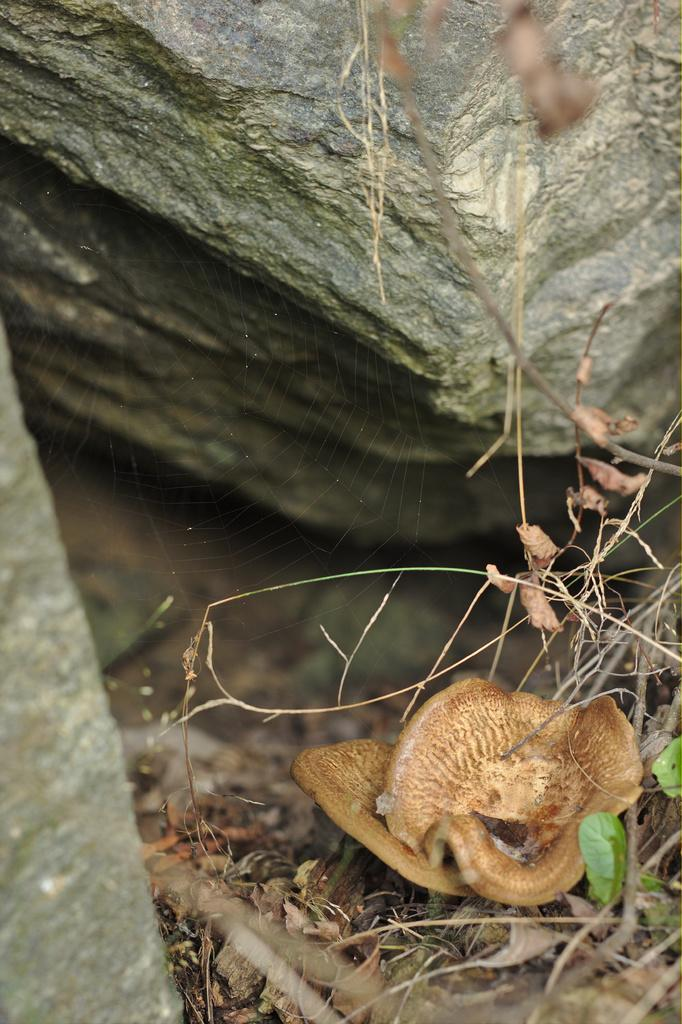What type of natural elements can be seen in the image? There are rocks and grass in the image. Can you describe the texture of the rocks? The texture of the rocks cannot be determined from the image alone. What type of vegetation is present in the image? Grass is the type of vegetation present in the image. What type of stem can be seen growing from the clover in the image? There is no clover present in the image, so there is no stem to describe. Can you tell me how many cushions are on the sofa in the image? There is no sofa present in the image. 